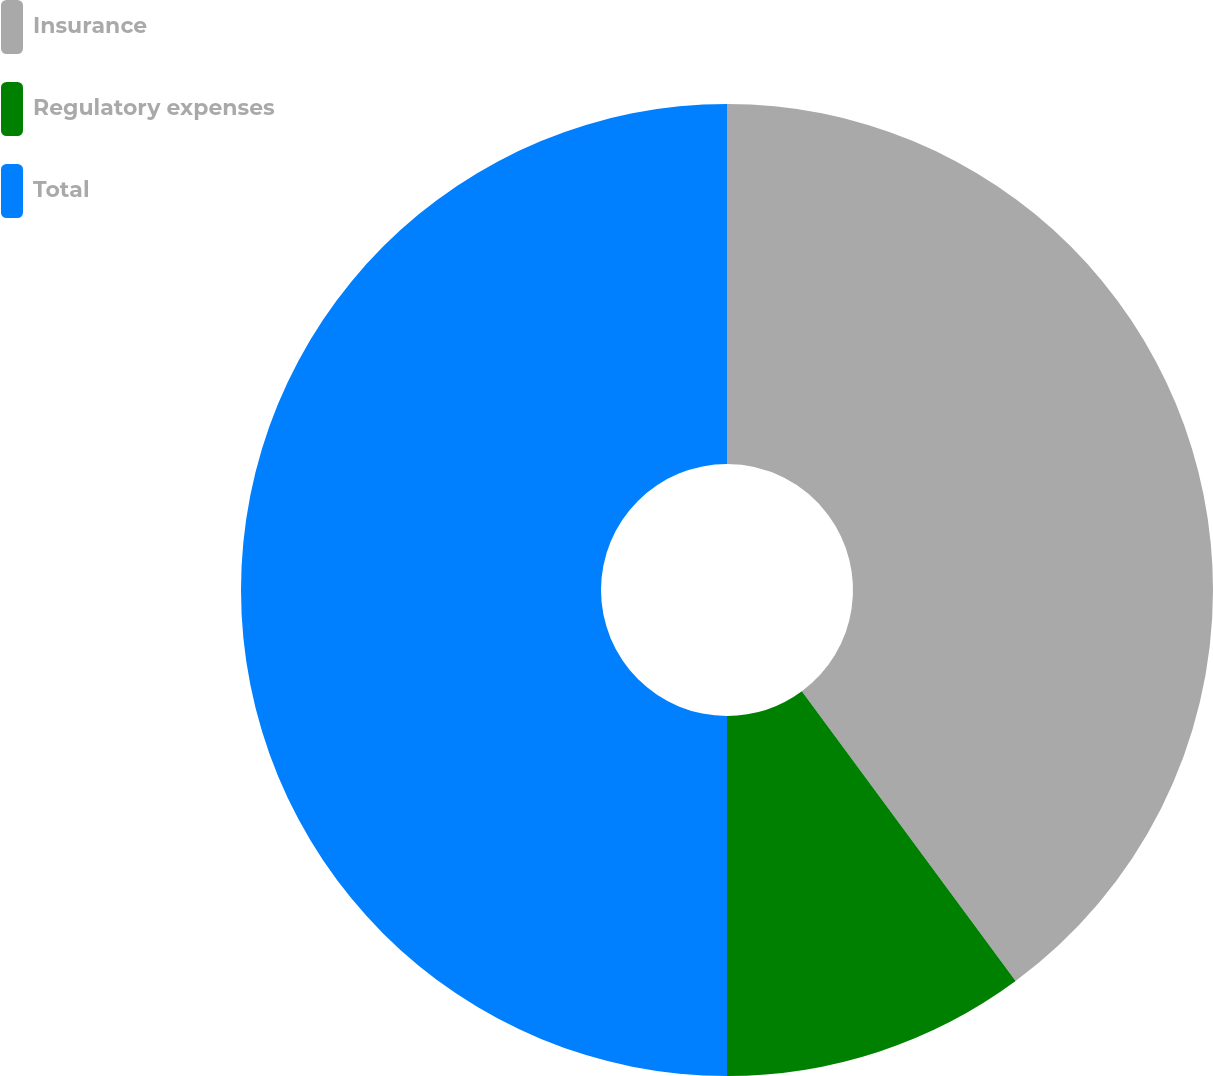<chart> <loc_0><loc_0><loc_500><loc_500><pie_chart><fcel>Insurance<fcel>Regulatory expenses<fcel>Total<nl><fcel>39.88%<fcel>10.12%<fcel>50.0%<nl></chart> 